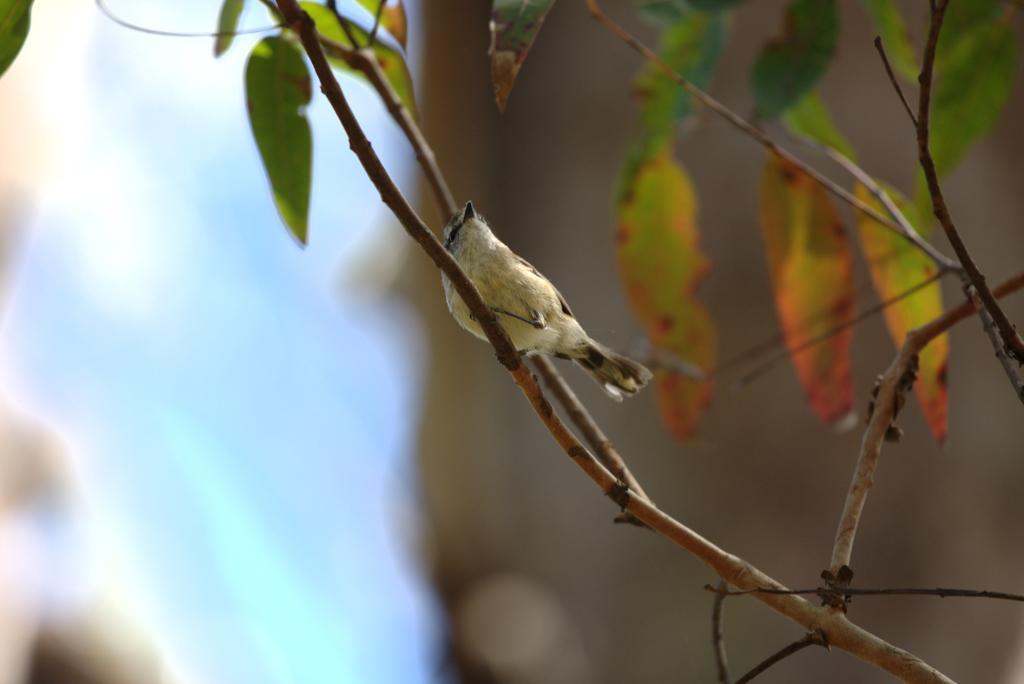What type of animal can be seen in the picture? There is a bird in the picture. Where is the bird positioned in the image? The bird is standing on a stem. What other elements are present in the picture besides the bird? There are leaves in the picture. Can you describe the background of the image? The background of the image is blurred. What type of record can be seen playing in the background of the image? There is no record present in the image; it features a bird standing on a stem with leaves in the background. Is there a lamp illuminating the bird in the image? There is no lamp visible in the image; the bird is standing on a stem with leaves in the background. 